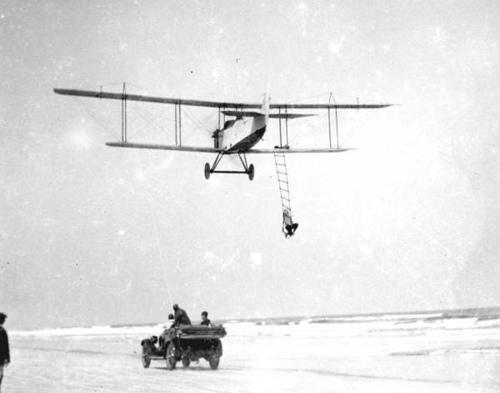How many wheels does the plane have?
Give a very brief answer. 2. How many trucks are there?
Give a very brief answer. 1. 